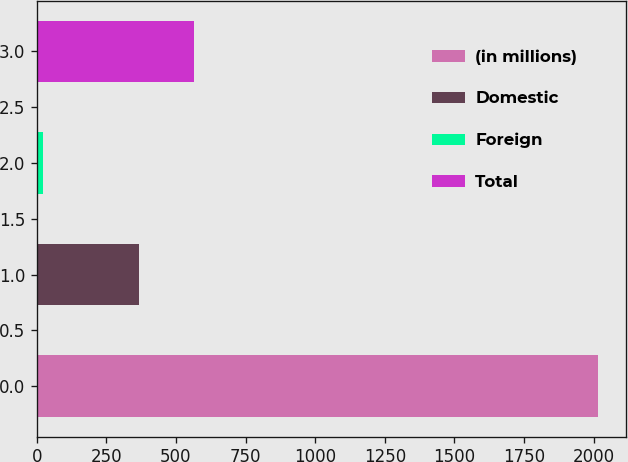Convert chart to OTSL. <chart><loc_0><loc_0><loc_500><loc_500><bar_chart><fcel>(in millions)<fcel>Domestic<fcel>Foreign<fcel>Total<nl><fcel>2014<fcel>366.6<fcel>21.1<fcel>565.89<nl></chart> 